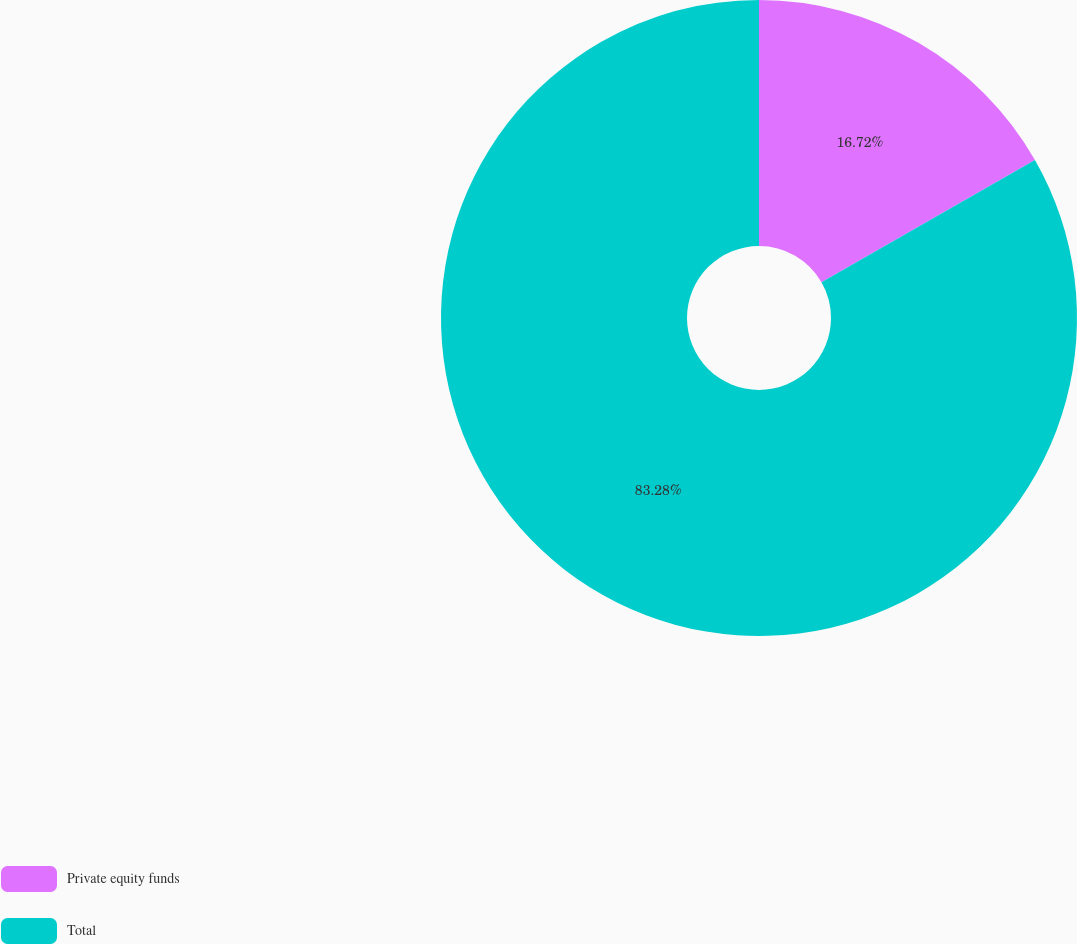Convert chart to OTSL. <chart><loc_0><loc_0><loc_500><loc_500><pie_chart><fcel>Private equity funds<fcel>Total<nl><fcel>16.72%<fcel>83.28%<nl></chart> 